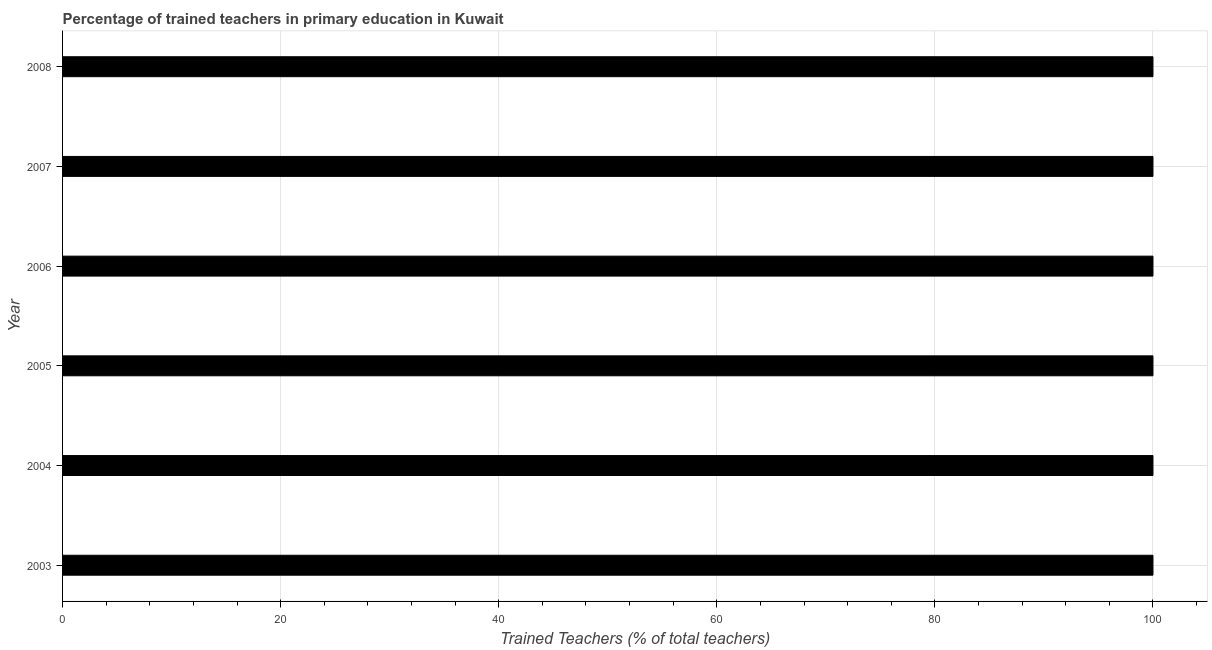Does the graph contain any zero values?
Provide a succinct answer. No. Does the graph contain grids?
Your answer should be compact. Yes. What is the title of the graph?
Offer a terse response. Percentage of trained teachers in primary education in Kuwait. What is the label or title of the X-axis?
Offer a terse response. Trained Teachers (% of total teachers). Across all years, what is the maximum percentage of trained teachers?
Provide a short and direct response. 100. Across all years, what is the minimum percentage of trained teachers?
Make the answer very short. 100. In which year was the percentage of trained teachers maximum?
Make the answer very short. 2003. In which year was the percentage of trained teachers minimum?
Give a very brief answer. 2003. What is the sum of the percentage of trained teachers?
Your answer should be compact. 600. What is the average percentage of trained teachers per year?
Ensure brevity in your answer.  100. What is the median percentage of trained teachers?
Give a very brief answer. 100. In how many years, is the percentage of trained teachers greater than 32 %?
Your answer should be very brief. 6. Do a majority of the years between 2008 and 2004 (inclusive) have percentage of trained teachers greater than 68 %?
Provide a succinct answer. Yes. What is the ratio of the percentage of trained teachers in 2007 to that in 2008?
Give a very brief answer. 1. Is the percentage of trained teachers in 2005 less than that in 2008?
Your response must be concise. No. How many bars are there?
Give a very brief answer. 6. What is the difference between two consecutive major ticks on the X-axis?
Provide a short and direct response. 20. What is the Trained Teachers (% of total teachers) of 2005?
Your answer should be very brief. 100. What is the Trained Teachers (% of total teachers) in 2006?
Your answer should be very brief. 100. What is the Trained Teachers (% of total teachers) of 2007?
Ensure brevity in your answer.  100. What is the difference between the Trained Teachers (% of total teachers) in 2003 and 2005?
Offer a very short reply. 0. What is the difference between the Trained Teachers (% of total teachers) in 2003 and 2008?
Offer a very short reply. 0. What is the difference between the Trained Teachers (% of total teachers) in 2004 and 2005?
Make the answer very short. 0. What is the difference between the Trained Teachers (% of total teachers) in 2004 and 2006?
Provide a short and direct response. 0. What is the difference between the Trained Teachers (% of total teachers) in 2004 and 2007?
Provide a short and direct response. 0. What is the difference between the Trained Teachers (% of total teachers) in 2005 and 2006?
Keep it short and to the point. 0. What is the difference between the Trained Teachers (% of total teachers) in 2005 and 2007?
Keep it short and to the point. 0. What is the difference between the Trained Teachers (% of total teachers) in 2005 and 2008?
Your answer should be very brief. 0. What is the difference between the Trained Teachers (% of total teachers) in 2006 and 2008?
Offer a terse response. 0. What is the ratio of the Trained Teachers (% of total teachers) in 2003 to that in 2004?
Give a very brief answer. 1. What is the ratio of the Trained Teachers (% of total teachers) in 2003 to that in 2006?
Make the answer very short. 1. What is the ratio of the Trained Teachers (% of total teachers) in 2003 to that in 2008?
Ensure brevity in your answer.  1. What is the ratio of the Trained Teachers (% of total teachers) in 2004 to that in 2006?
Your answer should be compact. 1. What is the ratio of the Trained Teachers (% of total teachers) in 2004 to that in 2007?
Ensure brevity in your answer.  1. What is the ratio of the Trained Teachers (% of total teachers) in 2004 to that in 2008?
Offer a terse response. 1. What is the ratio of the Trained Teachers (% of total teachers) in 2005 to that in 2006?
Offer a terse response. 1. What is the ratio of the Trained Teachers (% of total teachers) in 2005 to that in 2007?
Offer a terse response. 1. What is the ratio of the Trained Teachers (% of total teachers) in 2006 to that in 2008?
Ensure brevity in your answer.  1. 